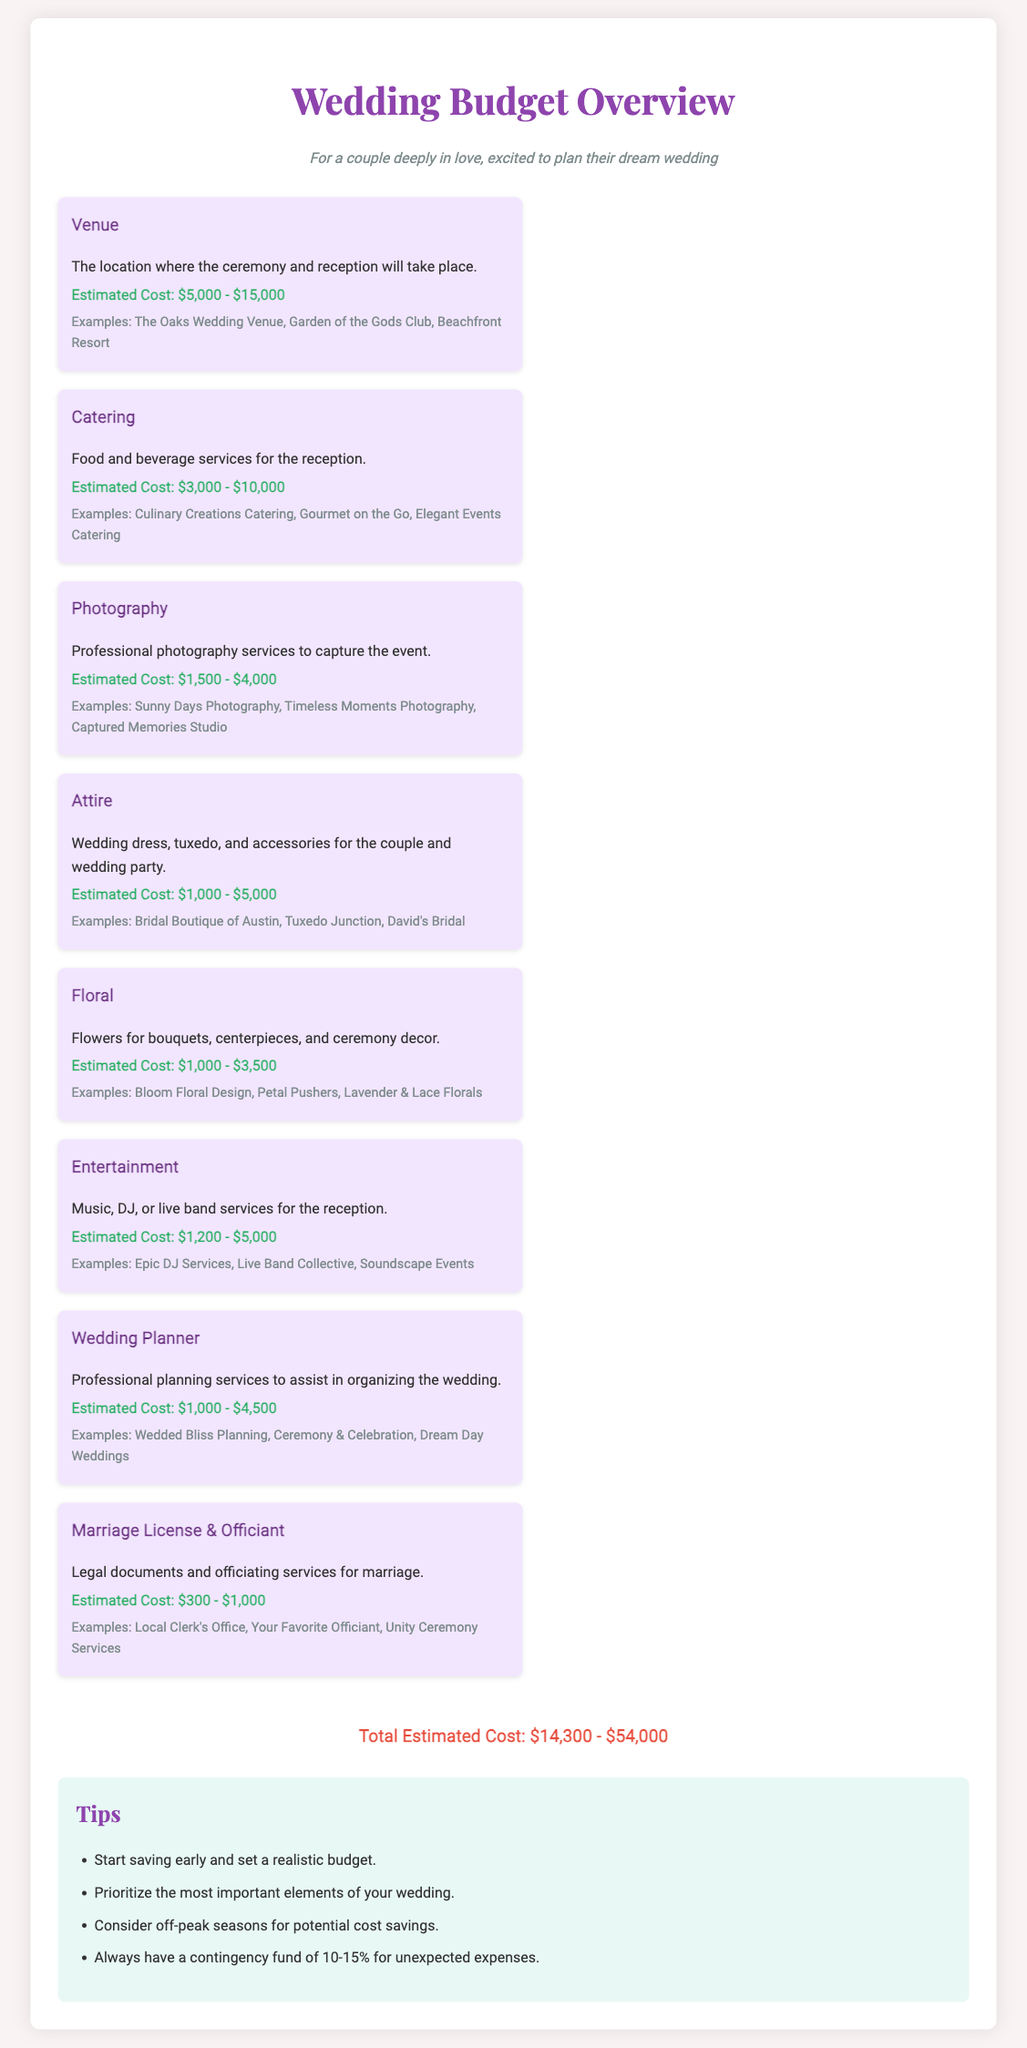What is the estimated cost range for the venue? The estimated cost range for the venue is presented in the document under the Venue category.
Answer: $5,000 - $15,000 What is the total estimated cost for the wedding? The total estimated cost is summarized at the bottom of the document.
Answer: $14,300 - $54,000 Which category has the lowest estimated cost range? By comparing the estimated cost ranges provided, the category with the lowest range can be identified.
Answer: $300 - $1,000 What services does the Photography category cover? The services covered in the Photography category are specified right after its title.
Answer: Professional photography services to capture the event What should be prioritized when planning a wedding? The tips section provides specific advice on planning considerations.
Answer: The most important elements of your wedding What is an example of a venue listed in the document? Examples of venues are provided in the Venue category for reference.
Answer: The Oaks Wedding Venue What is the purpose of hiring a wedding planner? The purpose of hiring a wedding planner is detailed in the Wedding Planner category.
Answer: Professional planning services to assist in organizing the wedding What is suggested for unexpected expenses? The tips section includes advice for managing unexpected costs.
Answer: A contingency fund of 10-15% 